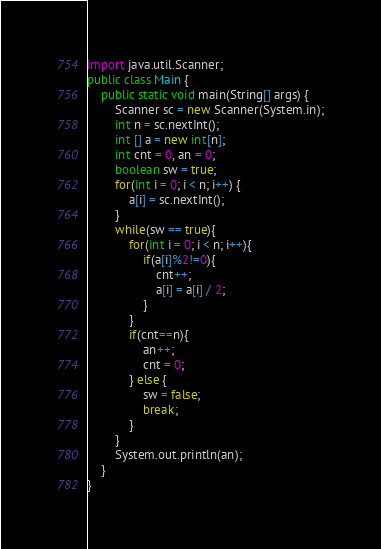Convert code to text. <code><loc_0><loc_0><loc_500><loc_500><_Java_>import java.util.Scanner;
public class Main {
	public static void main(String[] args) {
		Scanner sc = new Scanner(System.in);
		int n = sc.nextInt();
		int [] a = new int[n];
		int cnt = 0, an = 0;
		boolean sw = true;
		for(int i = 0; i < n; i++) {
			a[i] = sc.nextInt();
		}
		while(sw == true){
			for(int i = 0; i < n; i++){
				if(a[i]%2!=0){
					cnt++;
					a[i] = a[i] / 2;
				}
			}
			if(cnt==n){
				an++;
				cnt = 0;
			} else {
				sw = false;
				break;
			}
		}
		System.out.println(an);
	}
}
</code> 